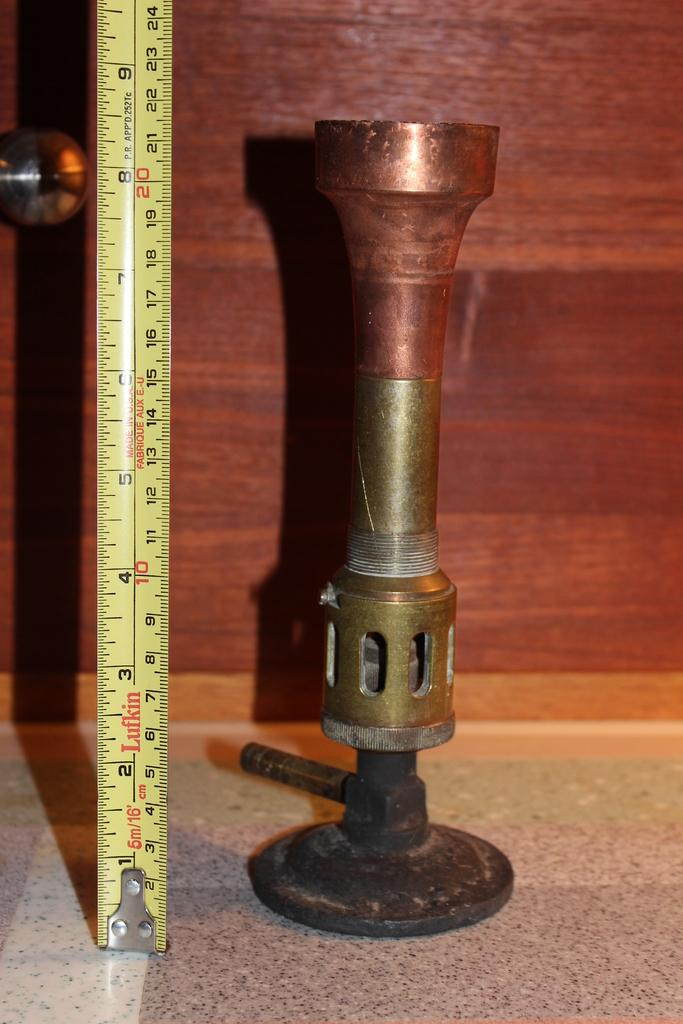<image>
Offer a succinct explanation of the picture presented. A Lufkin tape measure is stretched out measuring a metal object. 